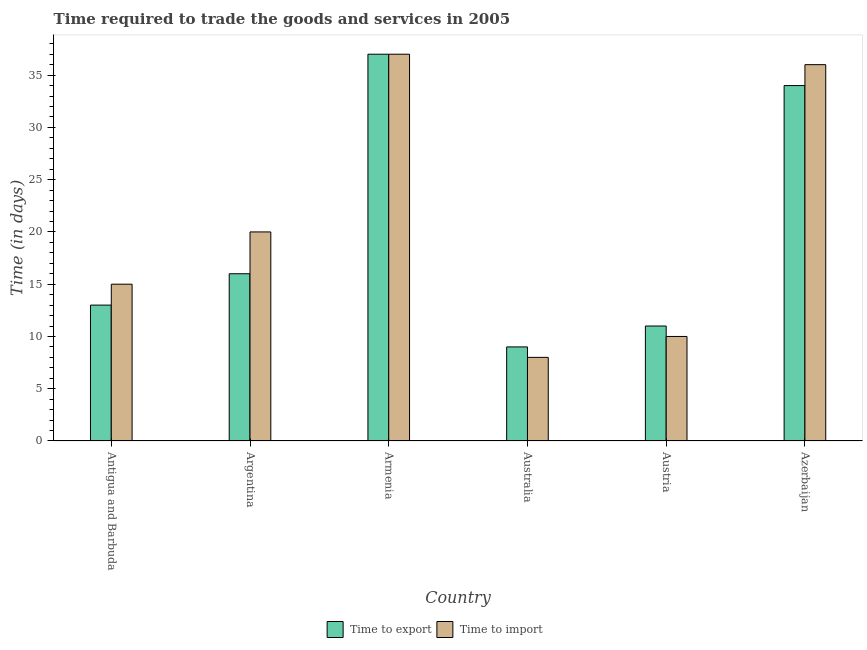How many different coloured bars are there?
Make the answer very short. 2. How many groups of bars are there?
Your answer should be very brief. 6. Are the number of bars per tick equal to the number of legend labels?
Ensure brevity in your answer.  Yes. Are the number of bars on each tick of the X-axis equal?
Provide a succinct answer. Yes. What is the label of the 6th group of bars from the left?
Your response must be concise. Azerbaijan. Across all countries, what is the minimum time to import?
Offer a very short reply. 8. In which country was the time to export maximum?
Ensure brevity in your answer.  Armenia. In which country was the time to import minimum?
Your answer should be compact. Australia. What is the total time to import in the graph?
Make the answer very short. 126. What is the difference between the time to export in Armenia and that in Australia?
Your answer should be compact. 28. What is the ratio of the time to export in Armenia to that in Australia?
Your answer should be compact. 4.11. Is the time to export in Australia less than that in Austria?
Ensure brevity in your answer.  Yes. Is the difference between the time to export in Armenia and Azerbaijan greater than the difference between the time to import in Armenia and Azerbaijan?
Ensure brevity in your answer.  Yes. In how many countries, is the time to export greater than the average time to export taken over all countries?
Give a very brief answer. 2. What does the 1st bar from the left in Australia represents?
Provide a short and direct response. Time to export. What does the 2nd bar from the right in Argentina represents?
Offer a very short reply. Time to export. Are all the bars in the graph horizontal?
Give a very brief answer. No. Are the values on the major ticks of Y-axis written in scientific E-notation?
Provide a succinct answer. No. Does the graph contain any zero values?
Give a very brief answer. No. Does the graph contain grids?
Give a very brief answer. No. Where does the legend appear in the graph?
Your answer should be compact. Bottom center. How many legend labels are there?
Your answer should be very brief. 2. What is the title of the graph?
Keep it short and to the point. Time required to trade the goods and services in 2005. Does "Under-5(female)" appear as one of the legend labels in the graph?
Give a very brief answer. No. What is the label or title of the Y-axis?
Provide a succinct answer. Time (in days). What is the Time (in days) in Time to import in Argentina?
Your answer should be compact. 20. What is the Time (in days) in Time to export in Armenia?
Make the answer very short. 37. What is the Time (in days) in Time to export in Australia?
Offer a terse response. 9. What is the Time (in days) in Time to export in Austria?
Your response must be concise. 11. What is the Time (in days) of Time to import in Austria?
Offer a terse response. 10. What is the Time (in days) of Time to import in Azerbaijan?
Make the answer very short. 36. Across all countries, what is the maximum Time (in days) in Time to import?
Your answer should be compact. 37. Across all countries, what is the minimum Time (in days) of Time to export?
Offer a very short reply. 9. Across all countries, what is the minimum Time (in days) in Time to import?
Your answer should be very brief. 8. What is the total Time (in days) in Time to export in the graph?
Provide a succinct answer. 120. What is the total Time (in days) in Time to import in the graph?
Give a very brief answer. 126. What is the difference between the Time (in days) in Time to import in Antigua and Barbuda and that in Armenia?
Provide a short and direct response. -22. What is the difference between the Time (in days) in Time to export in Antigua and Barbuda and that in Australia?
Provide a short and direct response. 4. What is the difference between the Time (in days) in Time to export in Antigua and Barbuda and that in Austria?
Keep it short and to the point. 2. What is the difference between the Time (in days) in Time to import in Antigua and Barbuda and that in Austria?
Make the answer very short. 5. What is the difference between the Time (in days) of Time to import in Antigua and Barbuda and that in Azerbaijan?
Your response must be concise. -21. What is the difference between the Time (in days) of Time to export in Argentina and that in Armenia?
Your answer should be compact. -21. What is the difference between the Time (in days) of Time to import in Argentina and that in Armenia?
Give a very brief answer. -17. What is the difference between the Time (in days) of Time to export in Argentina and that in Australia?
Your answer should be compact. 7. What is the difference between the Time (in days) of Time to export in Argentina and that in Azerbaijan?
Ensure brevity in your answer.  -18. What is the difference between the Time (in days) of Time to import in Argentina and that in Azerbaijan?
Your response must be concise. -16. What is the difference between the Time (in days) of Time to import in Armenia and that in Australia?
Your answer should be compact. 29. What is the difference between the Time (in days) of Time to export in Armenia and that in Austria?
Offer a terse response. 26. What is the difference between the Time (in days) in Time to export in Armenia and that in Azerbaijan?
Make the answer very short. 3. What is the difference between the Time (in days) of Time to export in Australia and that in Austria?
Your answer should be very brief. -2. What is the difference between the Time (in days) in Time to import in Australia and that in Austria?
Make the answer very short. -2. What is the difference between the Time (in days) of Time to export in Australia and that in Azerbaijan?
Your answer should be compact. -25. What is the difference between the Time (in days) in Time to import in Australia and that in Azerbaijan?
Keep it short and to the point. -28. What is the difference between the Time (in days) in Time to import in Austria and that in Azerbaijan?
Your answer should be very brief. -26. What is the difference between the Time (in days) in Time to export in Antigua and Barbuda and the Time (in days) in Time to import in Argentina?
Your response must be concise. -7. What is the difference between the Time (in days) in Time to export in Antigua and Barbuda and the Time (in days) in Time to import in Australia?
Provide a succinct answer. 5. What is the difference between the Time (in days) in Time to export in Antigua and Barbuda and the Time (in days) in Time to import in Azerbaijan?
Provide a succinct answer. -23. What is the difference between the Time (in days) of Time to export in Argentina and the Time (in days) of Time to import in Armenia?
Offer a terse response. -21. What is the difference between the Time (in days) in Time to export in Argentina and the Time (in days) in Time to import in Australia?
Provide a short and direct response. 8. What is the difference between the Time (in days) in Time to export in Argentina and the Time (in days) in Time to import in Azerbaijan?
Ensure brevity in your answer.  -20. What is the difference between the Time (in days) in Time to export in Armenia and the Time (in days) in Time to import in Australia?
Keep it short and to the point. 29. What is the difference between the Time (in days) of Time to export in Armenia and the Time (in days) of Time to import in Austria?
Make the answer very short. 27. What is the difference between the Time (in days) in Time to export in Armenia and the Time (in days) in Time to import in Azerbaijan?
Offer a terse response. 1. What is the difference between the Time (in days) of Time to export in Austria and the Time (in days) of Time to import in Azerbaijan?
Offer a very short reply. -25. What is the difference between the Time (in days) of Time to export and Time (in days) of Time to import in Antigua and Barbuda?
Your answer should be compact. -2. What is the difference between the Time (in days) of Time to export and Time (in days) of Time to import in Austria?
Your answer should be compact. 1. What is the difference between the Time (in days) in Time to export and Time (in days) in Time to import in Azerbaijan?
Give a very brief answer. -2. What is the ratio of the Time (in days) in Time to export in Antigua and Barbuda to that in Argentina?
Ensure brevity in your answer.  0.81. What is the ratio of the Time (in days) in Time to export in Antigua and Barbuda to that in Armenia?
Provide a succinct answer. 0.35. What is the ratio of the Time (in days) of Time to import in Antigua and Barbuda to that in Armenia?
Keep it short and to the point. 0.41. What is the ratio of the Time (in days) of Time to export in Antigua and Barbuda to that in Australia?
Offer a very short reply. 1.44. What is the ratio of the Time (in days) of Time to import in Antigua and Barbuda to that in Australia?
Offer a terse response. 1.88. What is the ratio of the Time (in days) of Time to export in Antigua and Barbuda to that in Austria?
Ensure brevity in your answer.  1.18. What is the ratio of the Time (in days) of Time to import in Antigua and Barbuda to that in Austria?
Offer a terse response. 1.5. What is the ratio of the Time (in days) in Time to export in Antigua and Barbuda to that in Azerbaijan?
Your answer should be compact. 0.38. What is the ratio of the Time (in days) of Time to import in Antigua and Barbuda to that in Azerbaijan?
Your answer should be compact. 0.42. What is the ratio of the Time (in days) of Time to export in Argentina to that in Armenia?
Provide a short and direct response. 0.43. What is the ratio of the Time (in days) in Time to import in Argentina to that in Armenia?
Ensure brevity in your answer.  0.54. What is the ratio of the Time (in days) in Time to export in Argentina to that in Australia?
Give a very brief answer. 1.78. What is the ratio of the Time (in days) of Time to export in Argentina to that in Austria?
Your response must be concise. 1.45. What is the ratio of the Time (in days) of Time to export in Argentina to that in Azerbaijan?
Keep it short and to the point. 0.47. What is the ratio of the Time (in days) in Time to import in Argentina to that in Azerbaijan?
Offer a terse response. 0.56. What is the ratio of the Time (in days) in Time to export in Armenia to that in Australia?
Keep it short and to the point. 4.11. What is the ratio of the Time (in days) of Time to import in Armenia to that in Australia?
Keep it short and to the point. 4.62. What is the ratio of the Time (in days) in Time to export in Armenia to that in Austria?
Your answer should be very brief. 3.36. What is the ratio of the Time (in days) in Time to import in Armenia to that in Austria?
Keep it short and to the point. 3.7. What is the ratio of the Time (in days) in Time to export in Armenia to that in Azerbaijan?
Provide a short and direct response. 1.09. What is the ratio of the Time (in days) in Time to import in Armenia to that in Azerbaijan?
Offer a terse response. 1.03. What is the ratio of the Time (in days) in Time to export in Australia to that in Austria?
Give a very brief answer. 0.82. What is the ratio of the Time (in days) in Time to export in Australia to that in Azerbaijan?
Keep it short and to the point. 0.26. What is the ratio of the Time (in days) of Time to import in Australia to that in Azerbaijan?
Keep it short and to the point. 0.22. What is the ratio of the Time (in days) in Time to export in Austria to that in Azerbaijan?
Offer a terse response. 0.32. What is the ratio of the Time (in days) in Time to import in Austria to that in Azerbaijan?
Offer a terse response. 0.28. What is the difference between the highest and the second highest Time (in days) of Time to import?
Give a very brief answer. 1. 